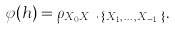<formula> <loc_0><loc_0><loc_500><loc_500>\varphi ( h ) = \rho _ { X _ { 0 } X _ { h } \, \cdot \, \{ X _ { 1 } , \, \dots \, , X _ { h - 1 } \} } .</formula> 